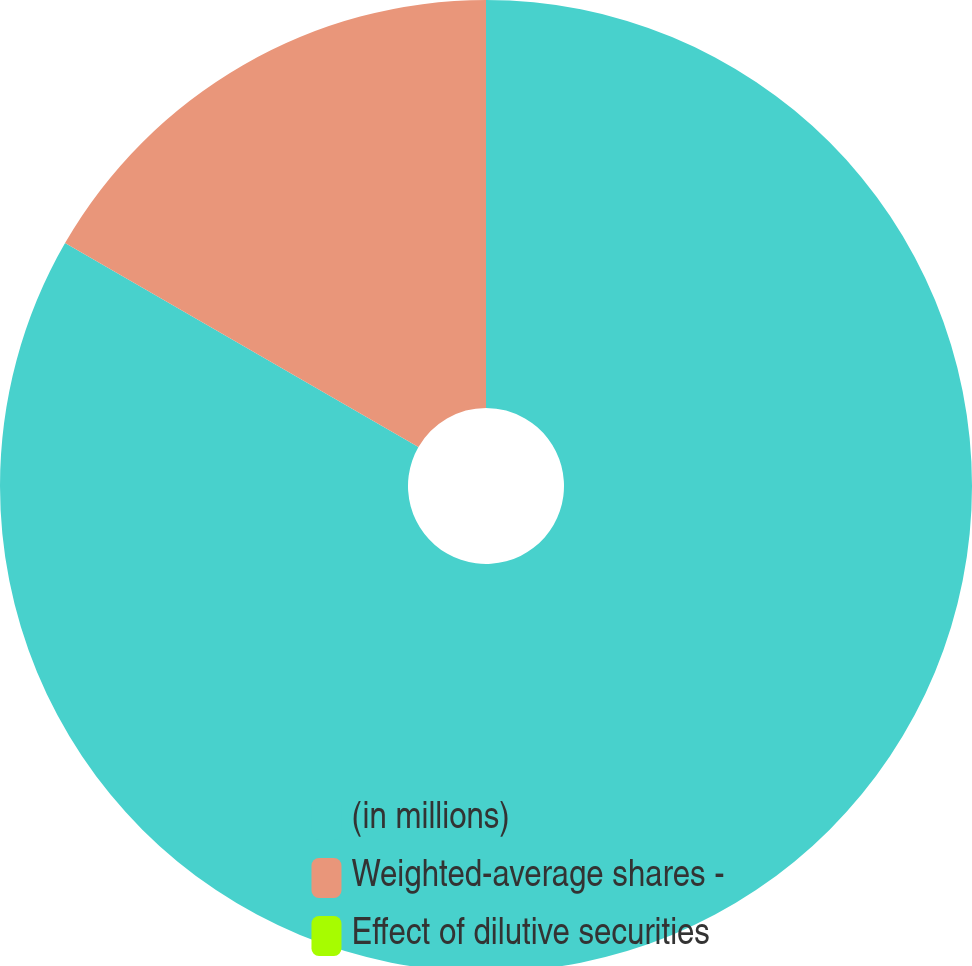Convert chart to OTSL. <chart><loc_0><loc_0><loc_500><loc_500><pie_chart><fcel>(in millions)<fcel>Weighted-average shares -<fcel>Effect of dilutive securities<nl><fcel>83.33%<fcel>16.67%<fcel>0.0%<nl></chart> 